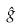<formula> <loc_0><loc_0><loc_500><loc_500>\hat { g }</formula> 